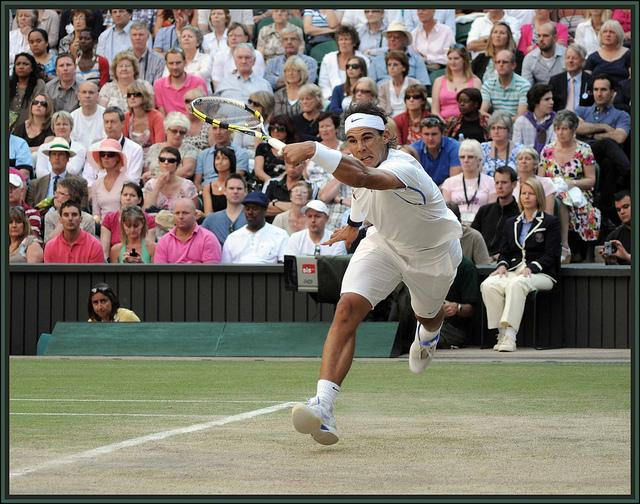What is the player's facial expression? Please explain your reasoning. focused. The man is determined. 